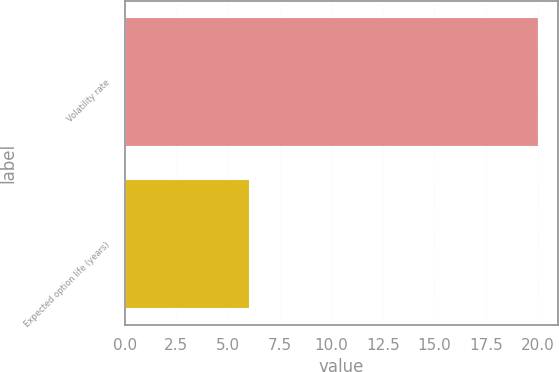Convert chart to OTSL. <chart><loc_0><loc_0><loc_500><loc_500><bar_chart><fcel>Volatility rate<fcel>Expected option life (years)<nl><fcel>20<fcel>6<nl></chart> 